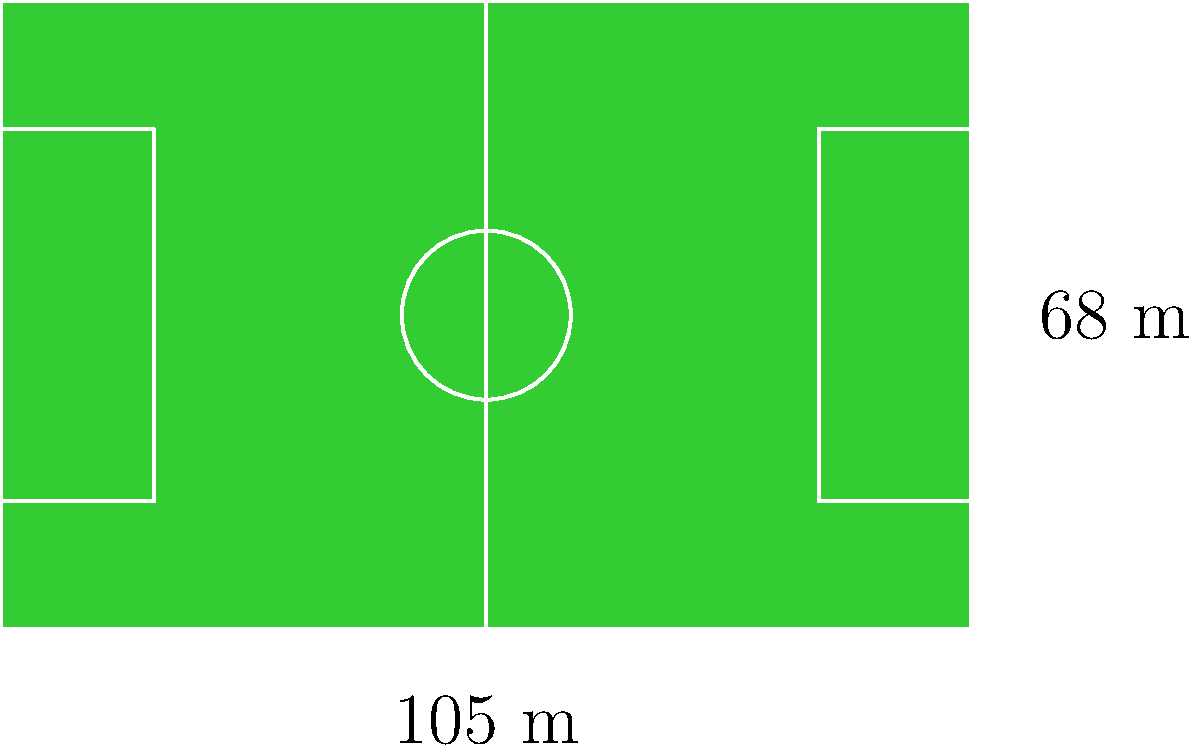The Ďolíček stadium, home of Bohemians 1905, has a football pitch with standard dimensions. If the pitch is 105 meters long and 68 meters wide, what is its total area in square meters? To calculate the area of the football pitch, we need to multiply its length by its width. Let's follow these steps:

1. Identify the dimensions:
   - Length = 105 meters
   - Width = 68 meters

2. Apply the formula for the area of a rectangle:
   $$ \text{Area} = \text{Length} \times \text{Width} $$

3. Substitute the values:
   $$ \text{Area} = 105 \text{ m} \times 68 \text{ m} $$

4. Perform the multiplication:
   $$ \text{Area} = 7,140 \text{ m}^2 $$

Therefore, the total area of the Ďolíček stadium's football pitch is 7,140 square meters.
Answer: 7,140 m² 